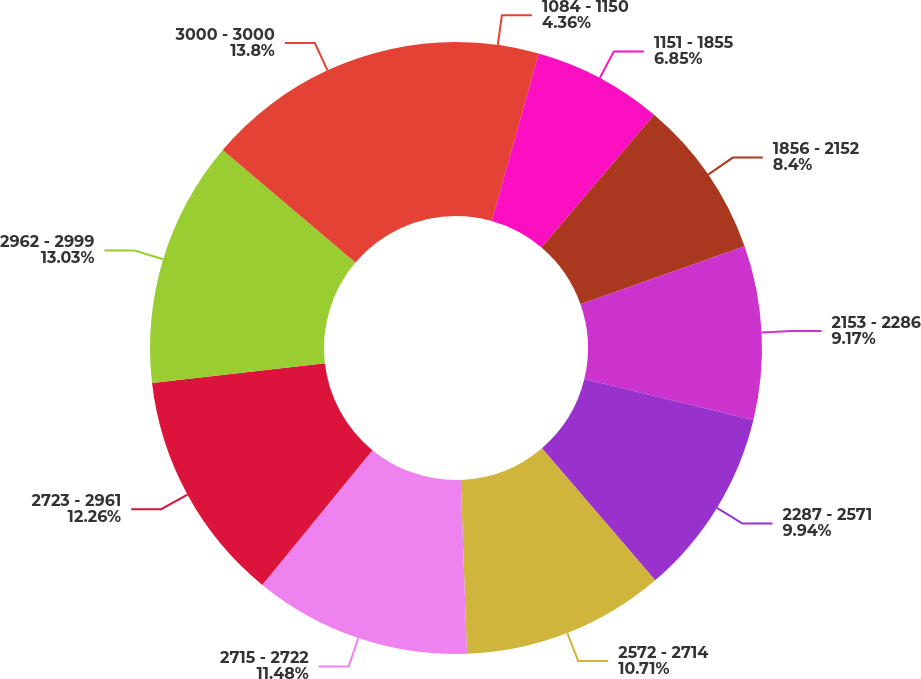Convert chart. <chart><loc_0><loc_0><loc_500><loc_500><pie_chart><fcel>1084 - 1150<fcel>1151 - 1855<fcel>1856 - 2152<fcel>2153 - 2286<fcel>2287 - 2571<fcel>2572 - 2714<fcel>2715 - 2722<fcel>2723 - 2961<fcel>2962 - 2999<fcel>3000 - 3000<nl><fcel>4.36%<fcel>6.85%<fcel>8.4%<fcel>9.17%<fcel>9.94%<fcel>10.71%<fcel>11.48%<fcel>12.26%<fcel>13.03%<fcel>13.8%<nl></chart> 